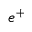<formula> <loc_0><loc_0><loc_500><loc_500>e ^ { + }</formula> 